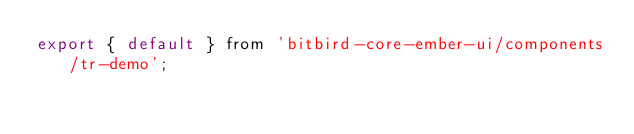Convert code to text. <code><loc_0><loc_0><loc_500><loc_500><_JavaScript_>export { default } from 'bitbird-core-ember-ui/components/tr-demo';
</code> 